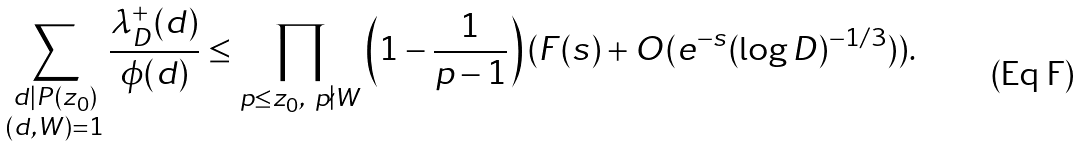<formula> <loc_0><loc_0><loc_500><loc_500>\sum _ { \substack { d | P ( z _ { 0 } ) \\ ( d , W ) = 1 } } \frac { \lambda _ { D } ^ { + } ( d ) } { \phi ( d ) } \leq \prod _ { p \leq z _ { 0 } , \ p \nmid W } \left ( 1 - \frac { 1 } { p - 1 } \right ) ( F ( s ) + O ( e ^ { - s } ( \log D ) ^ { - 1 / 3 } ) ) .</formula> 